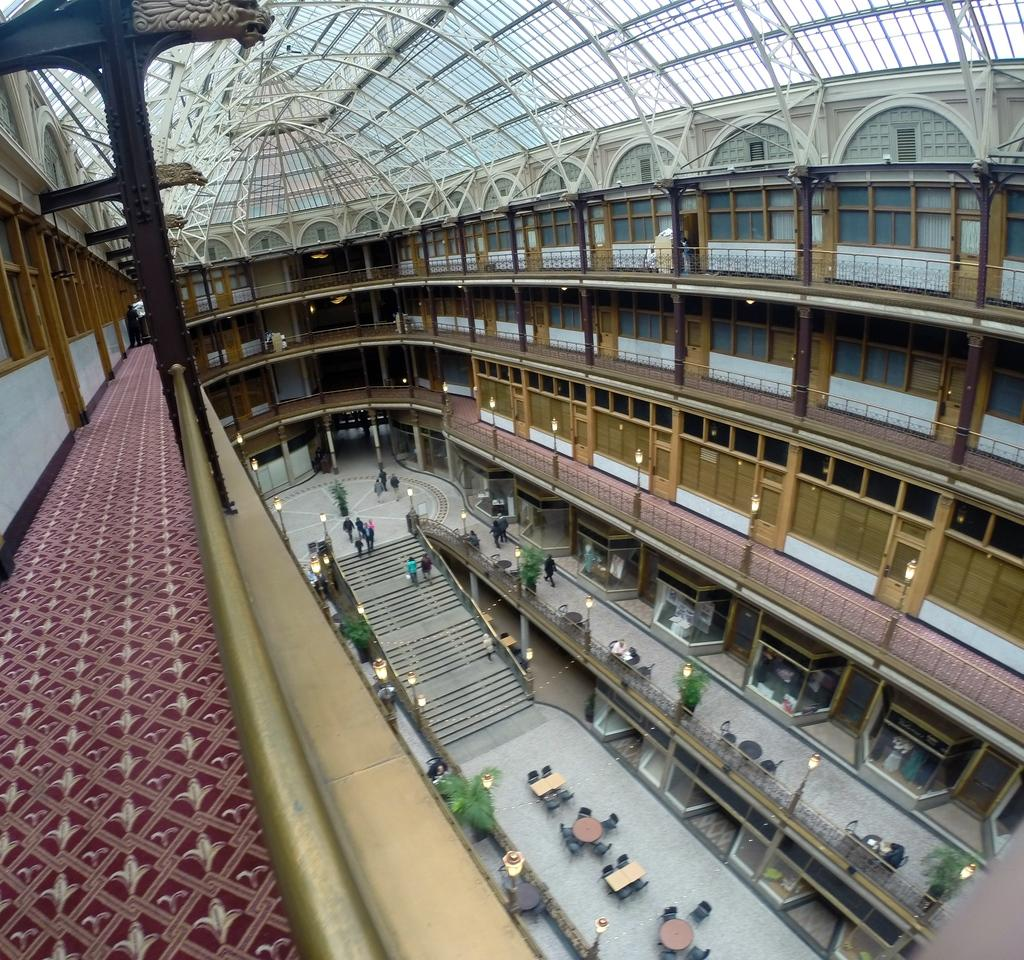What type of structure is present in the image? There is a building in the image. Can you describe the building's design? The building has multiple floors and a curved roof. What is happening on the ground floor of the building? There are people walking on the ground floor of the building. What type of seed is being planted in the image? There is no seed or planting activity present in the image; it features a building with people walking on the ground floor. Can you tell me what card game the people are playing in the image? There is no card game or any indication of a game being played in the image. 